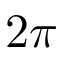<formula> <loc_0><loc_0><loc_500><loc_500>2 \pi</formula> 